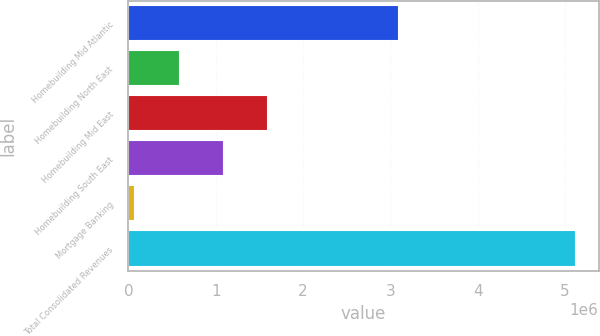Convert chart. <chart><loc_0><loc_0><loc_500><loc_500><bar_chart><fcel>Homebuilding Mid Atlantic<fcel>Homebuilding North East<fcel>Homebuilding Mid East<fcel>Homebuilding South East<fcel>Mortgage Banking<fcel>Total Consolidated Revenues<nl><fcel>3.09905e+06<fcel>585974<fcel>1.59561e+06<fcel>1.09079e+06<fcel>81155<fcel>5.12934e+06<nl></chart> 